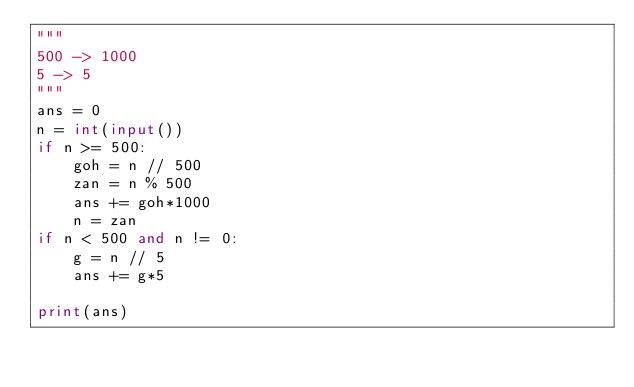Convert code to text. <code><loc_0><loc_0><loc_500><loc_500><_Python_>"""
500 -> 1000
5 -> 5
"""
ans = 0
n = int(input())
if n >= 500:
    goh = n // 500
    zan = n % 500
    ans += goh*1000
    n = zan
if n < 500 and n != 0:
    g = n // 5
    ans += g*5

print(ans)</code> 